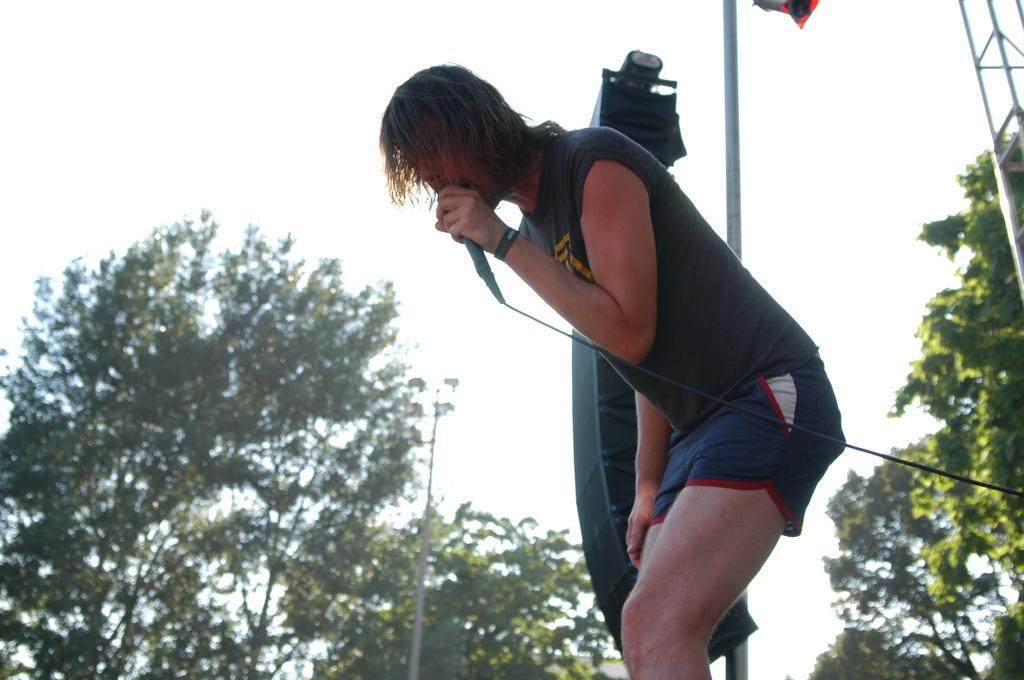Please provide a concise description of this image. In this image I can see a person ,holding a mike ,wearing a black color t-shirt at the top i can see the sky and trees and pole 